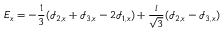<formula> <loc_0><loc_0><loc_500><loc_500>E _ { x } = - \frac { 1 } { 3 } ( \mathcal { I } _ { 2 , x } + \mathcal { I } _ { 3 , x } - 2 \mathcal { I } _ { 1 , x } ) + \frac { i } { \sqrt { 3 } } ( \mathcal { I } _ { 2 , x } - \mathcal { I } _ { 3 , x } )</formula> 